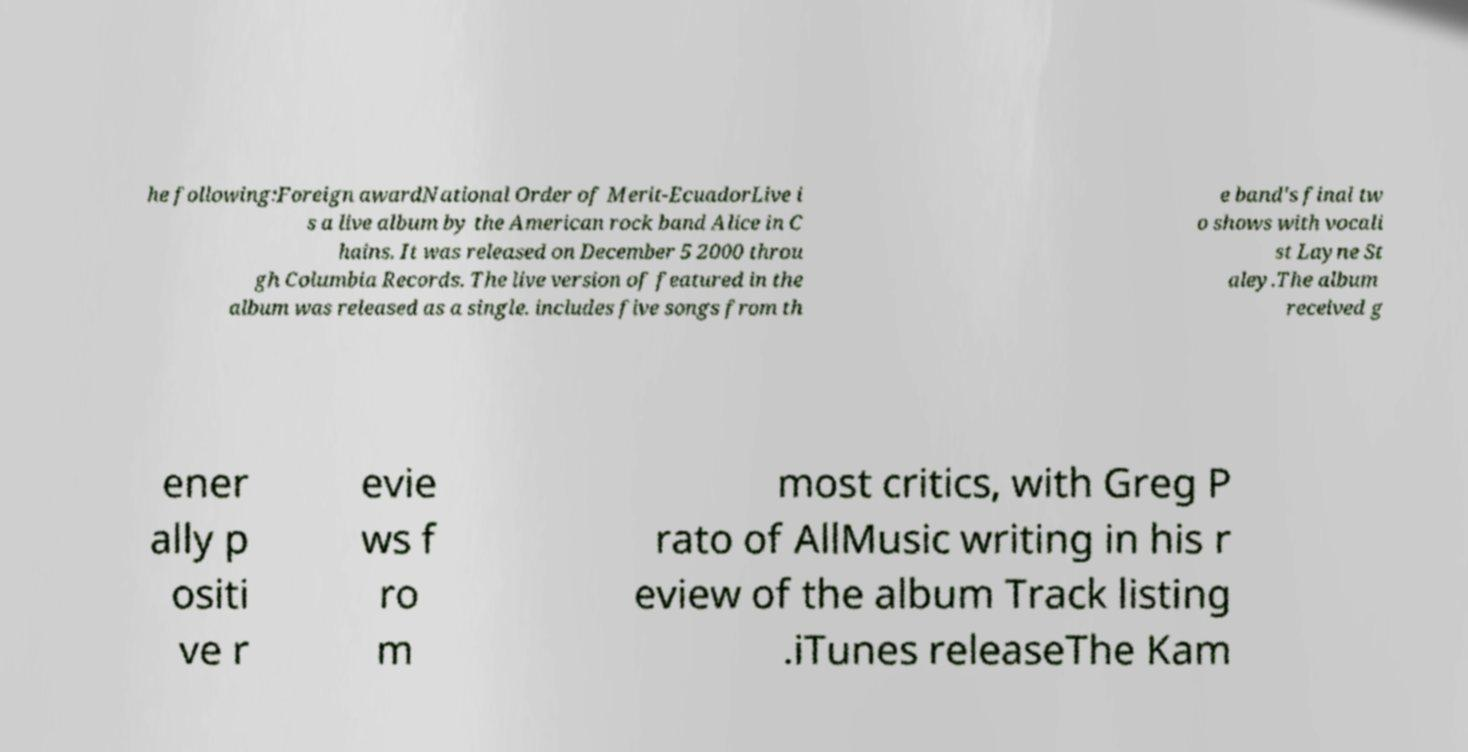For documentation purposes, I need the text within this image transcribed. Could you provide that? he following:Foreign awardNational Order of Merit-EcuadorLive i s a live album by the American rock band Alice in C hains. It was released on December 5 2000 throu gh Columbia Records. The live version of featured in the album was released as a single. includes five songs from th e band's final tw o shows with vocali st Layne St aley.The album received g ener ally p ositi ve r evie ws f ro m most critics, with Greg P rato of AllMusic writing in his r eview of the album Track listing .iTunes releaseThe Kam 